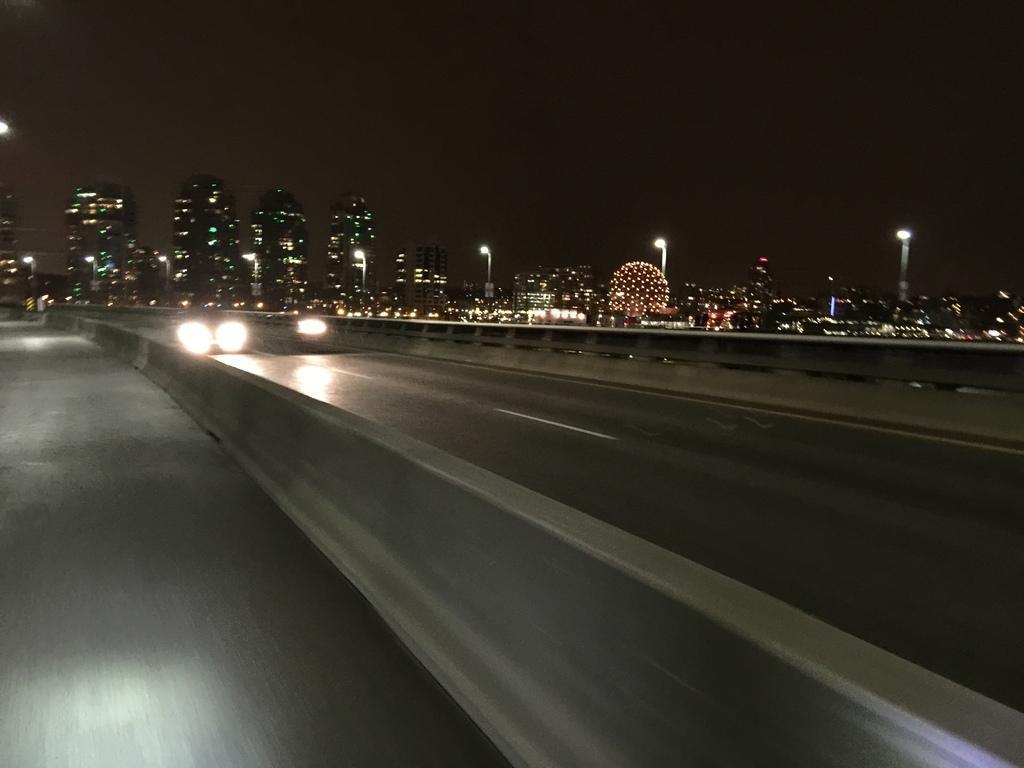Please provide a concise description of this image. In this image there is a road in the bottom of this image. There are some buildings and a current poles in the background. There is a sky on the top of this image. there are some lights of vehicles on the road as we can see on the left side of this image. 